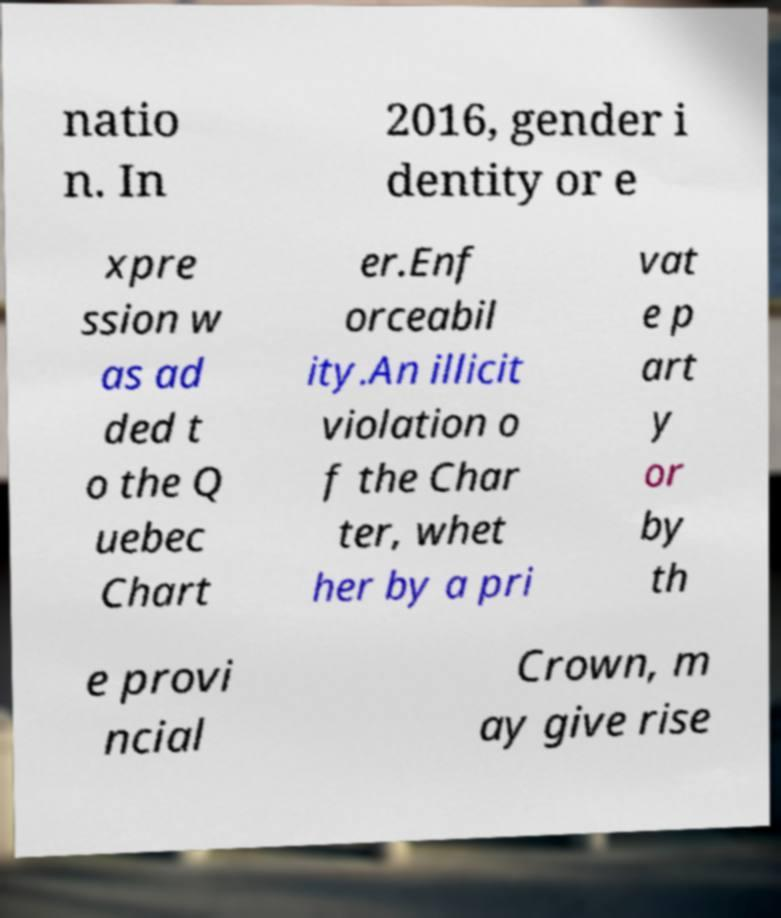Please read and relay the text visible in this image. What does it say? natio n. In 2016, gender i dentity or e xpre ssion w as ad ded t o the Q uebec Chart er.Enf orceabil ity.An illicit violation o f the Char ter, whet her by a pri vat e p art y or by th e provi ncial Crown, m ay give rise 